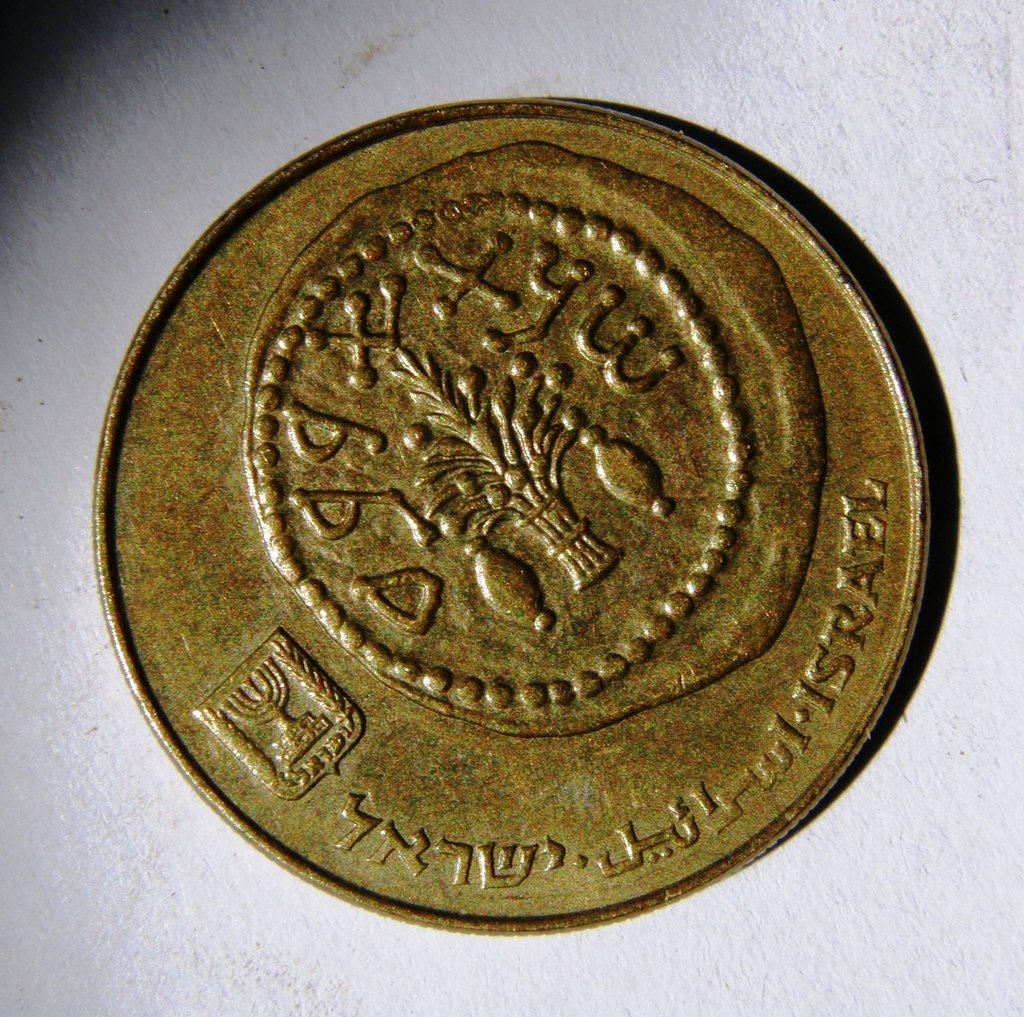What country is this from?
Give a very brief answer. Israel. The coin is all foreign language?
Your answer should be very brief. Yes. 